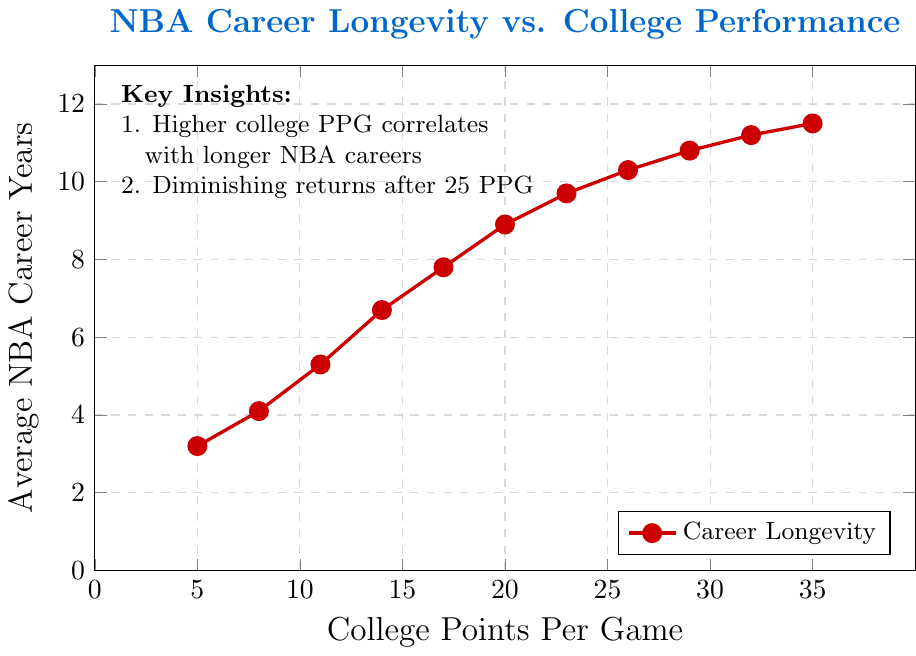What is the average NBA career length for a player who scored 20 points per game in college? Refer to the graph, find the data point where College PPG is 20. The corresponding average NBA career years is 8.9.
Answer: 8.9 By how many years does the NBA career length increase when college PPG goes from 5 to 20? Find the average NBA career years for College PPGs of 5 and 20, which are 3.2 and 8.9 respectively. Calculate the difference: 8.9 - 3.2 = 5.7 years.
Answer: 5.7 years What is the NBA career length for a player with a college PPG of 29? Look at the plot to find the data point where College PPG is 29. The corresponding average NBA career years is 10.8.
Answer: 10.8 How does the NBA career length change for every increase of 3 points in College PPG on average? To answer this, take the difference in career length between two points spaced by a gap of 3 PPG multiple times, e.g., from 5 PPG to 8 PPG (4.1 - 3.2), then 11 PPG (5.3 - 4.1), and so on. Calculate the average of these differences: (0.9 + 1.2 + 1.4 + 1.1 + 1.1 + 0.8 + 0.6 + 0.5 + 0.4 + 0.3) / 10 = 0.83.
Answer: 0.83 years By how many years does the NBA career length change when College PPG goes from 14 to 32? Identify the NBA career lengths for College PPGs of 14 and 32, which are 6.7 and 11.2 respectively. The difference is: 11.2 - 6.7 = 4.5 years.
Answer: 4.5 years Is there a point beyond which the increase in NBA career length starts to decrease with higher College PPG? Refer to the "Key Insights" in the plot mentioning diminishing returns after 25 College PPG. Observing visually, beyond 25 PPG, the career length increase rate slows down.
Answer: Yes Does NBA career length keep increasing linearly as College PPG increases? Check the graph’s general trend. It shows initial steep growth that later flattens, indicating non-linear growth.
Answer: No 